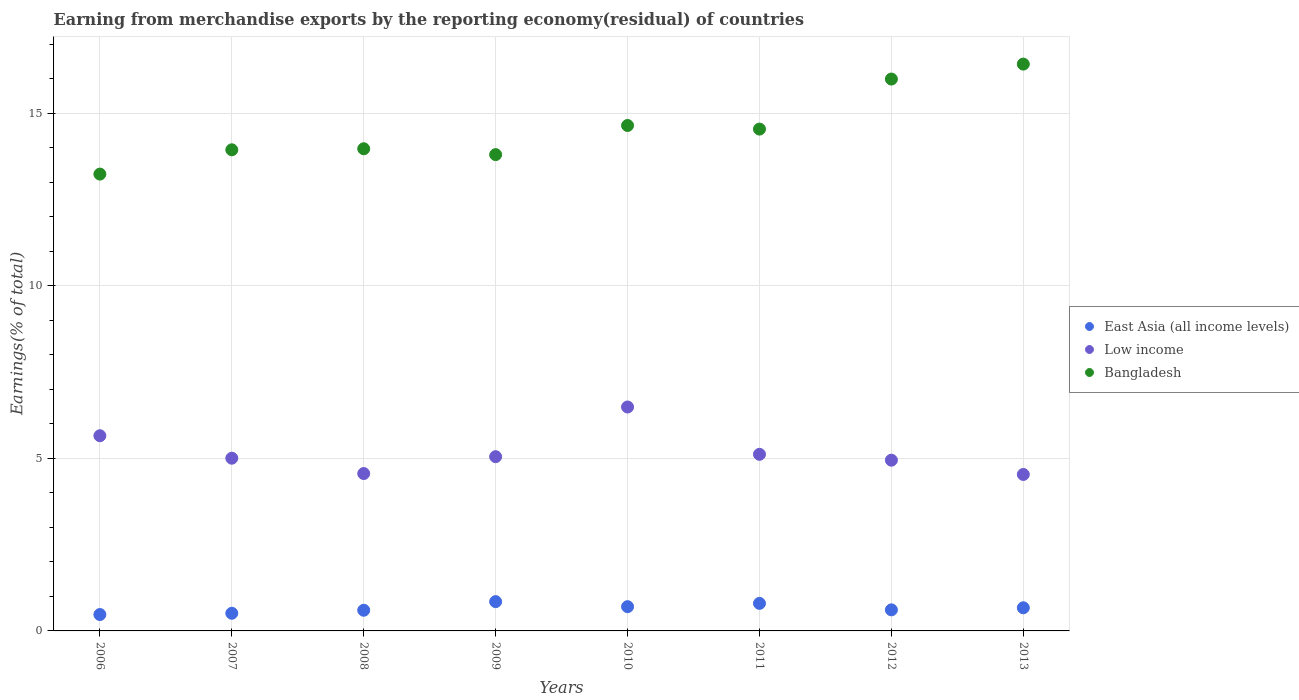What is the percentage of amount earned from merchandise exports in Low income in 2012?
Keep it short and to the point. 4.95. Across all years, what is the maximum percentage of amount earned from merchandise exports in East Asia (all income levels)?
Provide a succinct answer. 0.85. Across all years, what is the minimum percentage of amount earned from merchandise exports in Bangladesh?
Offer a terse response. 13.24. In which year was the percentage of amount earned from merchandise exports in Low income maximum?
Offer a very short reply. 2010. In which year was the percentage of amount earned from merchandise exports in Bangladesh minimum?
Your answer should be compact. 2006. What is the total percentage of amount earned from merchandise exports in East Asia (all income levels) in the graph?
Your answer should be very brief. 5.22. What is the difference between the percentage of amount earned from merchandise exports in Bangladesh in 2007 and that in 2010?
Offer a very short reply. -0.7. What is the difference between the percentage of amount earned from merchandise exports in Low income in 2008 and the percentage of amount earned from merchandise exports in East Asia (all income levels) in 2007?
Make the answer very short. 4.05. What is the average percentage of amount earned from merchandise exports in Bangladesh per year?
Your answer should be compact. 14.57. In the year 2013, what is the difference between the percentage of amount earned from merchandise exports in Bangladesh and percentage of amount earned from merchandise exports in East Asia (all income levels)?
Ensure brevity in your answer.  15.75. What is the ratio of the percentage of amount earned from merchandise exports in East Asia (all income levels) in 2007 to that in 2013?
Your answer should be compact. 0.76. What is the difference between the highest and the second highest percentage of amount earned from merchandise exports in Low income?
Ensure brevity in your answer.  0.83. What is the difference between the highest and the lowest percentage of amount earned from merchandise exports in Low income?
Make the answer very short. 1.95. In how many years, is the percentage of amount earned from merchandise exports in East Asia (all income levels) greater than the average percentage of amount earned from merchandise exports in East Asia (all income levels) taken over all years?
Offer a very short reply. 4. Is it the case that in every year, the sum of the percentage of amount earned from merchandise exports in Bangladesh and percentage of amount earned from merchandise exports in East Asia (all income levels)  is greater than the percentage of amount earned from merchandise exports in Low income?
Provide a succinct answer. Yes. Does the percentage of amount earned from merchandise exports in Bangladesh monotonically increase over the years?
Make the answer very short. No. Is the percentage of amount earned from merchandise exports in East Asia (all income levels) strictly greater than the percentage of amount earned from merchandise exports in Bangladesh over the years?
Your response must be concise. No. What is the difference between two consecutive major ticks on the Y-axis?
Your answer should be compact. 5. Does the graph contain any zero values?
Make the answer very short. No. How are the legend labels stacked?
Your answer should be compact. Vertical. What is the title of the graph?
Ensure brevity in your answer.  Earning from merchandise exports by the reporting economy(residual) of countries. What is the label or title of the Y-axis?
Make the answer very short. Earnings(% of total). What is the Earnings(% of total) in East Asia (all income levels) in 2006?
Provide a succinct answer. 0.47. What is the Earnings(% of total) in Low income in 2006?
Provide a succinct answer. 5.66. What is the Earnings(% of total) of Bangladesh in 2006?
Make the answer very short. 13.24. What is the Earnings(% of total) of East Asia (all income levels) in 2007?
Offer a very short reply. 0.51. What is the Earnings(% of total) of Low income in 2007?
Provide a succinct answer. 5. What is the Earnings(% of total) of Bangladesh in 2007?
Make the answer very short. 13.94. What is the Earnings(% of total) of East Asia (all income levels) in 2008?
Offer a terse response. 0.6. What is the Earnings(% of total) in Low income in 2008?
Your answer should be compact. 4.56. What is the Earnings(% of total) of Bangladesh in 2008?
Ensure brevity in your answer.  13.97. What is the Earnings(% of total) of East Asia (all income levels) in 2009?
Provide a succinct answer. 0.85. What is the Earnings(% of total) of Low income in 2009?
Provide a short and direct response. 5.05. What is the Earnings(% of total) of Bangladesh in 2009?
Your response must be concise. 13.8. What is the Earnings(% of total) of East Asia (all income levels) in 2010?
Offer a very short reply. 0.7. What is the Earnings(% of total) of Low income in 2010?
Your answer should be very brief. 6.49. What is the Earnings(% of total) of Bangladesh in 2010?
Keep it short and to the point. 14.64. What is the Earnings(% of total) in East Asia (all income levels) in 2011?
Make the answer very short. 0.8. What is the Earnings(% of total) in Low income in 2011?
Make the answer very short. 5.12. What is the Earnings(% of total) in Bangladesh in 2011?
Make the answer very short. 14.54. What is the Earnings(% of total) of East Asia (all income levels) in 2012?
Offer a very short reply. 0.61. What is the Earnings(% of total) of Low income in 2012?
Offer a very short reply. 4.95. What is the Earnings(% of total) of Bangladesh in 2012?
Provide a short and direct response. 15.99. What is the Earnings(% of total) in East Asia (all income levels) in 2013?
Offer a terse response. 0.67. What is the Earnings(% of total) in Low income in 2013?
Your answer should be very brief. 4.53. What is the Earnings(% of total) in Bangladesh in 2013?
Your answer should be very brief. 16.42. Across all years, what is the maximum Earnings(% of total) of East Asia (all income levels)?
Your answer should be compact. 0.85. Across all years, what is the maximum Earnings(% of total) in Low income?
Give a very brief answer. 6.49. Across all years, what is the maximum Earnings(% of total) of Bangladesh?
Ensure brevity in your answer.  16.42. Across all years, what is the minimum Earnings(% of total) of East Asia (all income levels)?
Offer a terse response. 0.47. Across all years, what is the minimum Earnings(% of total) of Low income?
Make the answer very short. 4.53. Across all years, what is the minimum Earnings(% of total) of Bangladesh?
Give a very brief answer. 13.24. What is the total Earnings(% of total) of East Asia (all income levels) in the graph?
Offer a terse response. 5.22. What is the total Earnings(% of total) in Low income in the graph?
Your response must be concise. 41.35. What is the total Earnings(% of total) in Bangladesh in the graph?
Your response must be concise. 116.55. What is the difference between the Earnings(% of total) in East Asia (all income levels) in 2006 and that in 2007?
Keep it short and to the point. -0.04. What is the difference between the Earnings(% of total) of Low income in 2006 and that in 2007?
Your response must be concise. 0.65. What is the difference between the Earnings(% of total) in Bangladesh in 2006 and that in 2007?
Your answer should be very brief. -0.7. What is the difference between the Earnings(% of total) of East Asia (all income levels) in 2006 and that in 2008?
Provide a short and direct response. -0.12. What is the difference between the Earnings(% of total) of Low income in 2006 and that in 2008?
Provide a short and direct response. 1.09. What is the difference between the Earnings(% of total) of Bangladesh in 2006 and that in 2008?
Your answer should be very brief. -0.73. What is the difference between the Earnings(% of total) in East Asia (all income levels) in 2006 and that in 2009?
Your answer should be compact. -0.37. What is the difference between the Earnings(% of total) in Low income in 2006 and that in 2009?
Offer a very short reply. 0.61. What is the difference between the Earnings(% of total) in Bangladesh in 2006 and that in 2009?
Your answer should be very brief. -0.56. What is the difference between the Earnings(% of total) in East Asia (all income levels) in 2006 and that in 2010?
Offer a very short reply. -0.23. What is the difference between the Earnings(% of total) of Low income in 2006 and that in 2010?
Give a very brief answer. -0.83. What is the difference between the Earnings(% of total) of Bangladesh in 2006 and that in 2010?
Ensure brevity in your answer.  -1.41. What is the difference between the Earnings(% of total) of East Asia (all income levels) in 2006 and that in 2011?
Provide a short and direct response. -0.32. What is the difference between the Earnings(% of total) of Low income in 2006 and that in 2011?
Your answer should be very brief. 0.54. What is the difference between the Earnings(% of total) of Bangladesh in 2006 and that in 2011?
Provide a succinct answer. -1.3. What is the difference between the Earnings(% of total) of East Asia (all income levels) in 2006 and that in 2012?
Offer a very short reply. -0.14. What is the difference between the Earnings(% of total) of Low income in 2006 and that in 2012?
Offer a terse response. 0.71. What is the difference between the Earnings(% of total) in Bangladesh in 2006 and that in 2012?
Make the answer very short. -2.75. What is the difference between the Earnings(% of total) in East Asia (all income levels) in 2006 and that in 2013?
Your response must be concise. -0.2. What is the difference between the Earnings(% of total) in Low income in 2006 and that in 2013?
Give a very brief answer. 1.12. What is the difference between the Earnings(% of total) of Bangladesh in 2006 and that in 2013?
Offer a very short reply. -3.19. What is the difference between the Earnings(% of total) in East Asia (all income levels) in 2007 and that in 2008?
Offer a terse response. -0.09. What is the difference between the Earnings(% of total) in Low income in 2007 and that in 2008?
Provide a succinct answer. 0.44. What is the difference between the Earnings(% of total) in Bangladesh in 2007 and that in 2008?
Provide a short and direct response. -0.03. What is the difference between the Earnings(% of total) of East Asia (all income levels) in 2007 and that in 2009?
Ensure brevity in your answer.  -0.34. What is the difference between the Earnings(% of total) of Low income in 2007 and that in 2009?
Keep it short and to the point. -0.04. What is the difference between the Earnings(% of total) of Bangladesh in 2007 and that in 2009?
Provide a short and direct response. 0.14. What is the difference between the Earnings(% of total) in East Asia (all income levels) in 2007 and that in 2010?
Your answer should be very brief. -0.19. What is the difference between the Earnings(% of total) of Low income in 2007 and that in 2010?
Make the answer very short. -1.48. What is the difference between the Earnings(% of total) of Bangladesh in 2007 and that in 2010?
Make the answer very short. -0.7. What is the difference between the Earnings(% of total) of East Asia (all income levels) in 2007 and that in 2011?
Keep it short and to the point. -0.29. What is the difference between the Earnings(% of total) in Low income in 2007 and that in 2011?
Provide a succinct answer. -0.11. What is the difference between the Earnings(% of total) in Bangladesh in 2007 and that in 2011?
Provide a succinct answer. -0.6. What is the difference between the Earnings(% of total) in East Asia (all income levels) in 2007 and that in 2012?
Offer a terse response. -0.1. What is the difference between the Earnings(% of total) of Low income in 2007 and that in 2012?
Offer a terse response. 0.06. What is the difference between the Earnings(% of total) in Bangladesh in 2007 and that in 2012?
Your answer should be compact. -2.05. What is the difference between the Earnings(% of total) in East Asia (all income levels) in 2007 and that in 2013?
Offer a terse response. -0.16. What is the difference between the Earnings(% of total) of Low income in 2007 and that in 2013?
Provide a short and direct response. 0.47. What is the difference between the Earnings(% of total) of Bangladesh in 2007 and that in 2013?
Give a very brief answer. -2.48. What is the difference between the Earnings(% of total) in East Asia (all income levels) in 2008 and that in 2009?
Ensure brevity in your answer.  -0.25. What is the difference between the Earnings(% of total) in Low income in 2008 and that in 2009?
Offer a very short reply. -0.49. What is the difference between the Earnings(% of total) in Bangladesh in 2008 and that in 2009?
Make the answer very short. 0.17. What is the difference between the Earnings(% of total) in East Asia (all income levels) in 2008 and that in 2010?
Offer a very short reply. -0.1. What is the difference between the Earnings(% of total) of Low income in 2008 and that in 2010?
Provide a short and direct response. -1.93. What is the difference between the Earnings(% of total) of Bangladesh in 2008 and that in 2010?
Provide a short and direct response. -0.67. What is the difference between the Earnings(% of total) of East Asia (all income levels) in 2008 and that in 2011?
Your response must be concise. -0.2. What is the difference between the Earnings(% of total) of Low income in 2008 and that in 2011?
Provide a succinct answer. -0.56. What is the difference between the Earnings(% of total) of Bangladesh in 2008 and that in 2011?
Your answer should be compact. -0.57. What is the difference between the Earnings(% of total) of East Asia (all income levels) in 2008 and that in 2012?
Provide a short and direct response. -0.01. What is the difference between the Earnings(% of total) in Low income in 2008 and that in 2012?
Your response must be concise. -0.39. What is the difference between the Earnings(% of total) in Bangladesh in 2008 and that in 2012?
Provide a short and direct response. -2.02. What is the difference between the Earnings(% of total) of East Asia (all income levels) in 2008 and that in 2013?
Ensure brevity in your answer.  -0.07. What is the difference between the Earnings(% of total) in Low income in 2008 and that in 2013?
Offer a very short reply. 0.03. What is the difference between the Earnings(% of total) in Bangladesh in 2008 and that in 2013?
Give a very brief answer. -2.45. What is the difference between the Earnings(% of total) in East Asia (all income levels) in 2009 and that in 2010?
Your answer should be very brief. 0.15. What is the difference between the Earnings(% of total) of Low income in 2009 and that in 2010?
Offer a terse response. -1.44. What is the difference between the Earnings(% of total) of Bangladesh in 2009 and that in 2010?
Provide a succinct answer. -0.84. What is the difference between the Earnings(% of total) in East Asia (all income levels) in 2009 and that in 2011?
Your answer should be very brief. 0.05. What is the difference between the Earnings(% of total) in Low income in 2009 and that in 2011?
Your answer should be compact. -0.07. What is the difference between the Earnings(% of total) of Bangladesh in 2009 and that in 2011?
Offer a very short reply. -0.74. What is the difference between the Earnings(% of total) of East Asia (all income levels) in 2009 and that in 2012?
Your response must be concise. 0.24. What is the difference between the Earnings(% of total) in Low income in 2009 and that in 2012?
Provide a succinct answer. 0.1. What is the difference between the Earnings(% of total) in Bangladesh in 2009 and that in 2012?
Provide a short and direct response. -2.19. What is the difference between the Earnings(% of total) of East Asia (all income levels) in 2009 and that in 2013?
Make the answer very short. 0.18. What is the difference between the Earnings(% of total) in Low income in 2009 and that in 2013?
Offer a very short reply. 0.51. What is the difference between the Earnings(% of total) of Bangladesh in 2009 and that in 2013?
Your response must be concise. -2.62. What is the difference between the Earnings(% of total) in East Asia (all income levels) in 2010 and that in 2011?
Ensure brevity in your answer.  -0.1. What is the difference between the Earnings(% of total) in Low income in 2010 and that in 2011?
Provide a succinct answer. 1.37. What is the difference between the Earnings(% of total) of Bangladesh in 2010 and that in 2011?
Offer a terse response. 0.1. What is the difference between the Earnings(% of total) of East Asia (all income levels) in 2010 and that in 2012?
Your answer should be very brief. 0.09. What is the difference between the Earnings(% of total) in Low income in 2010 and that in 2012?
Your answer should be very brief. 1.54. What is the difference between the Earnings(% of total) of Bangladesh in 2010 and that in 2012?
Make the answer very short. -1.35. What is the difference between the Earnings(% of total) in East Asia (all income levels) in 2010 and that in 2013?
Provide a short and direct response. 0.03. What is the difference between the Earnings(% of total) in Low income in 2010 and that in 2013?
Provide a short and direct response. 1.95. What is the difference between the Earnings(% of total) of Bangladesh in 2010 and that in 2013?
Your answer should be very brief. -1.78. What is the difference between the Earnings(% of total) in East Asia (all income levels) in 2011 and that in 2012?
Your response must be concise. 0.19. What is the difference between the Earnings(% of total) of Low income in 2011 and that in 2012?
Ensure brevity in your answer.  0.17. What is the difference between the Earnings(% of total) in Bangladesh in 2011 and that in 2012?
Make the answer very short. -1.45. What is the difference between the Earnings(% of total) in East Asia (all income levels) in 2011 and that in 2013?
Keep it short and to the point. 0.13. What is the difference between the Earnings(% of total) of Low income in 2011 and that in 2013?
Make the answer very short. 0.58. What is the difference between the Earnings(% of total) in Bangladesh in 2011 and that in 2013?
Ensure brevity in your answer.  -1.88. What is the difference between the Earnings(% of total) in East Asia (all income levels) in 2012 and that in 2013?
Give a very brief answer. -0.06. What is the difference between the Earnings(% of total) in Low income in 2012 and that in 2013?
Your answer should be compact. 0.41. What is the difference between the Earnings(% of total) in Bangladesh in 2012 and that in 2013?
Your answer should be very brief. -0.43. What is the difference between the Earnings(% of total) in East Asia (all income levels) in 2006 and the Earnings(% of total) in Low income in 2007?
Your answer should be very brief. -4.53. What is the difference between the Earnings(% of total) of East Asia (all income levels) in 2006 and the Earnings(% of total) of Bangladesh in 2007?
Your answer should be compact. -13.47. What is the difference between the Earnings(% of total) in Low income in 2006 and the Earnings(% of total) in Bangladesh in 2007?
Your answer should be very brief. -8.29. What is the difference between the Earnings(% of total) of East Asia (all income levels) in 2006 and the Earnings(% of total) of Low income in 2008?
Keep it short and to the point. -4.09. What is the difference between the Earnings(% of total) of East Asia (all income levels) in 2006 and the Earnings(% of total) of Bangladesh in 2008?
Make the answer very short. -13.5. What is the difference between the Earnings(% of total) in Low income in 2006 and the Earnings(% of total) in Bangladesh in 2008?
Make the answer very short. -8.32. What is the difference between the Earnings(% of total) of East Asia (all income levels) in 2006 and the Earnings(% of total) of Low income in 2009?
Your response must be concise. -4.57. What is the difference between the Earnings(% of total) in East Asia (all income levels) in 2006 and the Earnings(% of total) in Bangladesh in 2009?
Make the answer very short. -13.33. What is the difference between the Earnings(% of total) in Low income in 2006 and the Earnings(% of total) in Bangladesh in 2009?
Offer a very short reply. -8.15. What is the difference between the Earnings(% of total) in East Asia (all income levels) in 2006 and the Earnings(% of total) in Low income in 2010?
Provide a succinct answer. -6.01. What is the difference between the Earnings(% of total) in East Asia (all income levels) in 2006 and the Earnings(% of total) in Bangladesh in 2010?
Give a very brief answer. -14.17. What is the difference between the Earnings(% of total) in Low income in 2006 and the Earnings(% of total) in Bangladesh in 2010?
Give a very brief answer. -8.99. What is the difference between the Earnings(% of total) in East Asia (all income levels) in 2006 and the Earnings(% of total) in Low income in 2011?
Provide a succinct answer. -4.64. What is the difference between the Earnings(% of total) of East Asia (all income levels) in 2006 and the Earnings(% of total) of Bangladesh in 2011?
Offer a very short reply. -14.07. What is the difference between the Earnings(% of total) in Low income in 2006 and the Earnings(% of total) in Bangladesh in 2011?
Your response must be concise. -8.89. What is the difference between the Earnings(% of total) in East Asia (all income levels) in 2006 and the Earnings(% of total) in Low income in 2012?
Make the answer very short. -4.47. What is the difference between the Earnings(% of total) of East Asia (all income levels) in 2006 and the Earnings(% of total) of Bangladesh in 2012?
Give a very brief answer. -15.52. What is the difference between the Earnings(% of total) in Low income in 2006 and the Earnings(% of total) in Bangladesh in 2012?
Give a very brief answer. -10.34. What is the difference between the Earnings(% of total) of East Asia (all income levels) in 2006 and the Earnings(% of total) of Low income in 2013?
Keep it short and to the point. -4.06. What is the difference between the Earnings(% of total) of East Asia (all income levels) in 2006 and the Earnings(% of total) of Bangladesh in 2013?
Ensure brevity in your answer.  -15.95. What is the difference between the Earnings(% of total) in Low income in 2006 and the Earnings(% of total) in Bangladesh in 2013?
Keep it short and to the point. -10.77. What is the difference between the Earnings(% of total) of East Asia (all income levels) in 2007 and the Earnings(% of total) of Low income in 2008?
Give a very brief answer. -4.05. What is the difference between the Earnings(% of total) in East Asia (all income levels) in 2007 and the Earnings(% of total) in Bangladesh in 2008?
Your answer should be very brief. -13.46. What is the difference between the Earnings(% of total) of Low income in 2007 and the Earnings(% of total) of Bangladesh in 2008?
Make the answer very short. -8.97. What is the difference between the Earnings(% of total) in East Asia (all income levels) in 2007 and the Earnings(% of total) in Low income in 2009?
Your response must be concise. -4.54. What is the difference between the Earnings(% of total) in East Asia (all income levels) in 2007 and the Earnings(% of total) in Bangladesh in 2009?
Provide a short and direct response. -13.29. What is the difference between the Earnings(% of total) of Low income in 2007 and the Earnings(% of total) of Bangladesh in 2009?
Give a very brief answer. -8.8. What is the difference between the Earnings(% of total) in East Asia (all income levels) in 2007 and the Earnings(% of total) in Low income in 2010?
Your answer should be very brief. -5.98. What is the difference between the Earnings(% of total) in East Asia (all income levels) in 2007 and the Earnings(% of total) in Bangladesh in 2010?
Your answer should be very brief. -14.13. What is the difference between the Earnings(% of total) in Low income in 2007 and the Earnings(% of total) in Bangladesh in 2010?
Offer a very short reply. -9.64. What is the difference between the Earnings(% of total) in East Asia (all income levels) in 2007 and the Earnings(% of total) in Low income in 2011?
Offer a very short reply. -4.61. What is the difference between the Earnings(% of total) in East Asia (all income levels) in 2007 and the Earnings(% of total) in Bangladesh in 2011?
Provide a short and direct response. -14.03. What is the difference between the Earnings(% of total) of Low income in 2007 and the Earnings(% of total) of Bangladesh in 2011?
Give a very brief answer. -9.54. What is the difference between the Earnings(% of total) of East Asia (all income levels) in 2007 and the Earnings(% of total) of Low income in 2012?
Give a very brief answer. -4.44. What is the difference between the Earnings(% of total) in East Asia (all income levels) in 2007 and the Earnings(% of total) in Bangladesh in 2012?
Your answer should be very brief. -15.48. What is the difference between the Earnings(% of total) in Low income in 2007 and the Earnings(% of total) in Bangladesh in 2012?
Offer a very short reply. -10.99. What is the difference between the Earnings(% of total) in East Asia (all income levels) in 2007 and the Earnings(% of total) in Low income in 2013?
Make the answer very short. -4.02. What is the difference between the Earnings(% of total) in East Asia (all income levels) in 2007 and the Earnings(% of total) in Bangladesh in 2013?
Keep it short and to the point. -15.91. What is the difference between the Earnings(% of total) in Low income in 2007 and the Earnings(% of total) in Bangladesh in 2013?
Give a very brief answer. -11.42. What is the difference between the Earnings(% of total) of East Asia (all income levels) in 2008 and the Earnings(% of total) of Low income in 2009?
Make the answer very short. -4.45. What is the difference between the Earnings(% of total) of East Asia (all income levels) in 2008 and the Earnings(% of total) of Bangladesh in 2009?
Your response must be concise. -13.2. What is the difference between the Earnings(% of total) in Low income in 2008 and the Earnings(% of total) in Bangladesh in 2009?
Keep it short and to the point. -9.24. What is the difference between the Earnings(% of total) in East Asia (all income levels) in 2008 and the Earnings(% of total) in Low income in 2010?
Your answer should be very brief. -5.89. What is the difference between the Earnings(% of total) in East Asia (all income levels) in 2008 and the Earnings(% of total) in Bangladesh in 2010?
Offer a terse response. -14.05. What is the difference between the Earnings(% of total) of Low income in 2008 and the Earnings(% of total) of Bangladesh in 2010?
Give a very brief answer. -10.08. What is the difference between the Earnings(% of total) of East Asia (all income levels) in 2008 and the Earnings(% of total) of Low income in 2011?
Provide a short and direct response. -4.52. What is the difference between the Earnings(% of total) in East Asia (all income levels) in 2008 and the Earnings(% of total) in Bangladesh in 2011?
Offer a very short reply. -13.94. What is the difference between the Earnings(% of total) in Low income in 2008 and the Earnings(% of total) in Bangladesh in 2011?
Make the answer very short. -9.98. What is the difference between the Earnings(% of total) in East Asia (all income levels) in 2008 and the Earnings(% of total) in Low income in 2012?
Make the answer very short. -4.35. What is the difference between the Earnings(% of total) of East Asia (all income levels) in 2008 and the Earnings(% of total) of Bangladesh in 2012?
Offer a terse response. -15.39. What is the difference between the Earnings(% of total) in Low income in 2008 and the Earnings(% of total) in Bangladesh in 2012?
Your response must be concise. -11.43. What is the difference between the Earnings(% of total) in East Asia (all income levels) in 2008 and the Earnings(% of total) in Low income in 2013?
Give a very brief answer. -3.93. What is the difference between the Earnings(% of total) of East Asia (all income levels) in 2008 and the Earnings(% of total) of Bangladesh in 2013?
Keep it short and to the point. -15.82. What is the difference between the Earnings(% of total) of Low income in 2008 and the Earnings(% of total) of Bangladesh in 2013?
Offer a terse response. -11.86. What is the difference between the Earnings(% of total) of East Asia (all income levels) in 2009 and the Earnings(% of total) of Low income in 2010?
Offer a terse response. -5.64. What is the difference between the Earnings(% of total) of East Asia (all income levels) in 2009 and the Earnings(% of total) of Bangladesh in 2010?
Your answer should be compact. -13.8. What is the difference between the Earnings(% of total) of Low income in 2009 and the Earnings(% of total) of Bangladesh in 2010?
Give a very brief answer. -9.6. What is the difference between the Earnings(% of total) in East Asia (all income levels) in 2009 and the Earnings(% of total) in Low income in 2011?
Keep it short and to the point. -4.27. What is the difference between the Earnings(% of total) in East Asia (all income levels) in 2009 and the Earnings(% of total) in Bangladesh in 2011?
Provide a short and direct response. -13.69. What is the difference between the Earnings(% of total) of Low income in 2009 and the Earnings(% of total) of Bangladesh in 2011?
Keep it short and to the point. -9.49. What is the difference between the Earnings(% of total) of East Asia (all income levels) in 2009 and the Earnings(% of total) of Low income in 2012?
Provide a succinct answer. -4.1. What is the difference between the Earnings(% of total) of East Asia (all income levels) in 2009 and the Earnings(% of total) of Bangladesh in 2012?
Offer a terse response. -15.14. What is the difference between the Earnings(% of total) in Low income in 2009 and the Earnings(% of total) in Bangladesh in 2012?
Provide a short and direct response. -10.94. What is the difference between the Earnings(% of total) of East Asia (all income levels) in 2009 and the Earnings(% of total) of Low income in 2013?
Your answer should be compact. -3.68. What is the difference between the Earnings(% of total) in East Asia (all income levels) in 2009 and the Earnings(% of total) in Bangladesh in 2013?
Give a very brief answer. -15.57. What is the difference between the Earnings(% of total) of Low income in 2009 and the Earnings(% of total) of Bangladesh in 2013?
Your response must be concise. -11.38. What is the difference between the Earnings(% of total) of East Asia (all income levels) in 2010 and the Earnings(% of total) of Low income in 2011?
Offer a very short reply. -4.41. What is the difference between the Earnings(% of total) in East Asia (all income levels) in 2010 and the Earnings(% of total) in Bangladesh in 2011?
Your answer should be very brief. -13.84. What is the difference between the Earnings(% of total) in Low income in 2010 and the Earnings(% of total) in Bangladesh in 2011?
Provide a short and direct response. -8.05. What is the difference between the Earnings(% of total) in East Asia (all income levels) in 2010 and the Earnings(% of total) in Low income in 2012?
Keep it short and to the point. -4.24. What is the difference between the Earnings(% of total) of East Asia (all income levels) in 2010 and the Earnings(% of total) of Bangladesh in 2012?
Give a very brief answer. -15.29. What is the difference between the Earnings(% of total) in Low income in 2010 and the Earnings(% of total) in Bangladesh in 2012?
Offer a terse response. -9.5. What is the difference between the Earnings(% of total) in East Asia (all income levels) in 2010 and the Earnings(% of total) in Low income in 2013?
Make the answer very short. -3.83. What is the difference between the Earnings(% of total) of East Asia (all income levels) in 2010 and the Earnings(% of total) of Bangladesh in 2013?
Ensure brevity in your answer.  -15.72. What is the difference between the Earnings(% of total) of Low income in 2010 and the Earnings(% of total) of Bangladesh in 2013?
Provide a succinct answer. -9.94. What is the difference between the Earnings(% of total) of East Asia (all income levels) in 2011 and the Earnings(% of total) of Low income in 2012?
Your answer should be compact. -4.15. What is the difference between the Earnings(% of total) of East Asia (all income levels) in 2011 and the Earnings(% of total) of Bangladesh in 2012?
Ensure brevity in your answer.  -15.19. What is the difference between the Earnings(% of total) in Low income in 2011 and the Earnings(% of total) in Bangladesh in 2012?
Offer a terse response. -10.87. What is the difference between the Earnings(% of total) of East Asia (all income levels) in 2011 and the Earnings(% of total) of Low income in 2013?
Your answer should be compact. -3.74. What is the difference between the Earnings(% of total) in East Asia (all income levels) in 2011 and the Earnings(% of total) in Bangladesh in 2013?
Provide a short and direct response. -15.63. What is the difference between the Earnings(% of total) of Low income in 2011 and the Earnings(% of total) of Bangladesh in 2013?
Give a very brief answer. -11.31. What is the difference between the Earnings(% of total) in East Asia (all income levels) in 2012 and the Earnings(% of total) in Low income in 2013?
Offer a terse response. -3.92. What is the difference between the Earnings(% of total) in East Asia (all income levels) in 2012 and the Earnings(% of total) in Bangladesh in 2013?
Your response must be concise. -15.81. What is the difference between the Earnings(% of total) in Low income in 2012 and the Earnings(% of total) in Bangladesh in 2013?
Your answer should be very brief. -11.48. What is the average Earnings(% of total) in East Asia (all income levels) per year?
Make the answer very short. 0.65. What is the average Earnings(% of total) of Low income per year?
Keep it short and to the point. 5.17. What is the average Earnings(% of total) in Bangladesh per year?
Offer a terse response. 14.57. In the year 2006, what is the difference between the Earnings(% of total) in East Asia (all income levels) and Earnings(% of total) in Low income?
Your answer should be very brief. -5.18. In the year 2006, what is the difference between the Earnings(% of total) of East Asia (all income levels) and Earnings(% of total) of Bangladesh?
Offer a very short reply. -12.76. In the year 2006, what is the difference between the Earnings(% of total) in Low income and Earnings(% of total) in Bangladesh?
Your answer should be compact. -7.58. In the year 2007, what is the difference between the Earnings(% of total) of East Asia (all income levels) and Earnings(% of total) of Low income?
Give a very brief answer. -4.49. In the year 2007, what is the difference between the Earnings(% of total) of East Asia (all income levels) and Earnings(% of total) of Bangladesh?
Your response must be concise. -13.43. In the year 2007, what is the difference between the Earnings(% of total) of Low income and Earnings(% of total) of Bangladesh?
Offer a terse response. -8.94. In the year 2008, what is the difference between the Earnings(% of total) in East Asia (all income levels) and Earnings(% of total) in Low income?
Your answer should be very brief. -3.96. In the year 2008, what is the difference between the Earnings(% of total) in East Asia (all income levels) and Earnings(% of total) in Bangladesh?
Your answer should be compact. -13.37. In the year 2008, what is the difference between the Earnings(% of total) in Low income and Earnings(% of total) in Bangladesh?
Your answer should be compact. -9.41. In the year 2009, what is the difference between the Earnings(% of total) of East Asia (all income levels) and Earnings(% of total) of Low income?
Your response must be concise. -4.2. In the year 2009, what is the difference between the Earnings(% of total) in East Asia (all income levels) and Earnings(% of total) in Bangladesh?
Your answer should be compact. -12.95. In the year 2009, what is the difference between the Earnings(% of total) of Low income and Earnings(% of total) of Bangladesh?
Keep it short and to the point. -8.75. In the year 2010, what is the difference between the Earnings(% of total) of East Asia (all income levels) and Earnings(% of total) of Low income?
Make the answer very short. -5.79. In the year 2010, what is the difference between the Earnings(% of total) in East Asia (all income levels) and Earnings(% of total) in Bangladesh?
Your answer should be compact. -13.94. In the year 2010, what is the difference between the Earnings(% of total) of Low income and Earnings(% of total) of Bangladesh?
Provide a succinct answer. -8.16. In the year 2011, what is the difference between the Earnings(% of total) in East Asia (all income levels) and Earnings(% of total) in Low income?
Your answer should be compact. -4.32. In the year 2011, what is the difference between the Earnings(% of total) of East Asia (all income levels) and Earnings(% of total) of Bangladesh?
Provide a short and direct response. -13.74. In the year 2011, what is the difference between the Earnings(% of total) in Low income and Earnings(% of total) in Bangladesh?
Your answer should be compact. -9.42. In the year 2012, what is the difference between the Earnings(% of total) of East Asia (all income levels) and Earnings(% of total) of Low income?
Provide a short and direct response. -4.34. In the year 2012, what is the difference between the Earnings(% of total) in East Asia (all income levels) and Earnings(% of total) in Bangladesh?
Your response must be concise. -15.38. In the year 2012, what is the difference between the Earnings(% of total) in Low income and Earnings(% of total) in Bangladesh?
Offer a terse response. -11.04. In the year 2013, what is the difference between the Earnings(% of total) of East Asia (all income levels) and Earnings(% of total) of Low income?
Offer a very short reply. -3.86. In the year 2013, what is the difference between the Earnings(% of total) of East Asia (all income levels) and Earnings(% of total) of Bangladesh?
Your answer should be compact. -15.75. In the year 2013, what is the difference between the Earnings(% of total) in Low income and Earnings(% of total) in Bangladesh?
Your answer should be compact. -11.89. What is the ratio of the Earnings(% of total) in East Asia (all income levels) in 2006 to that in 2007?
Make the answer very short. 0.93. What is the ratio of the Earnings(% of total) in Low income in 2006 to that in 2007?
Make the answer very short. 1.13. What is the ratio of the Earnings(% of total) in Bangladesh in 2006 to that in 2007?
Provide a succinct answer. 0.95. What is the ratio of the Earnings(% of total) in East Asia (all income levels) in 2006 to that in 2008?
Keep it short and to the point. 0.79. What is the ratio of the Earnings(% of total) of Low income in 2006 to that in 2008?
Provide a succinct answer. 1.24. What is the ratio of the Earnings(% of total) of Bangladesh in 2006 to that in 2008?
Your answer should be compact. 0.95. What is the ratio of the Earnings(% of total) of East Asia (all income levels) in 2006 to that in 2009?
Your response must be concise. 0.56. What is the ratio of the Earnings(% of total) of Low income in 2006 to that in 2009?
Ensure brevity in your answer.  1.12. What is the ratio of the Earnings(% of total) in Bangladesh in 2006 to that in 2009?
Give a very brief answer. 0.96. What is the ratio of the Earnings(% of total) of East Asia (all income levels) in 2006 to that in 2010?
Provide a succinct answer. 0.68. What is the ratio of the Earnings(% of total) in Low income in 2006 to that in 2010?
Provide a succinct answer. 0.87. What is the ratio of the Earnings(% of total) of Bangladesh in 2006 to that in 2010?
Give a very brief answer. 0.9. What is the ratio of the Earnings(% of total) in East Asia (all income levels) in 2006 to that in 2011?
Your response must be concise. 0.6. What is the ratio of the Earnings(% of total) of Low income in 2006 to that in 2011?
Ensure brevity in your answer.  1.11. What is the ratio of the Earnings(% of total) in Bangladesh in 2006 to that in 2011?
Keep it short and to the point. 0.91. What is the ratio of the Earnings(% of total) of East Asia (all income levels) in 2006 to that in 2012?
Ensure brevity in your answer.  0.78. What is the ratio of the Earnings(% of total) in Low income in 2006 to that in 2012?
Keep it short and to the point. 1.14. What is the ratio of the Earnings(% of total) of Bangladesh in 2006 to that in 2012?
Your response must be concise. 0.83. What is the ratio of the Earnings(% of total) in East Asia (all income levels) in 2006 to that in 2013?
Ensure brevity in your answer.  0.71. What is the ratio of the Earnings(% of total) in Low income in 2006 to that in 2013?
Your answer should be compact. 1.25. What is the ratio of the Earnings(% of total) of Bangladesh in 2006 to that in 2013?
Offer a very short reply. 0.81. What is the ratio of the Earnings(% of total) of East Asia (all income levels) in 2007 to that in 2008?
Offer a terse response. 0.85. What is the ratio of the Earnings(% of total) of Low income in 2007 to that in 2008?
Provide a short and direct response. 1.1. What is the ratio of the Earnings(% of total) in Bangladesh in 2007 to that in 2008?
Your answer should be very brief. 1. What is the ratio of the Earnings(% of total) in East Asia (all income levels) in 2007 to that in 2009?
Your response must be concise. 0.6. What is the ratio of the Earnings(% of total) in East Asia (all income levels) in 2007 to that in 2010?
Your answer should be compact. 0.73. What is the ratio of the Earnings(% of total) of Low income in 2007 to that in 2010?
Make the answer very short. 0.77. What is the ratio of the Earnings(% of total) of Bangladesh in 2007 to that in 2010?
Offer a very short reply. 0.95. What is the ratio of the Earnings(% of total) of East Asia (all income levels) in 2007 to that in 2011?
Offer a very short reply. 0.64. What is the ratio of the Earnings(% of total) of Low income in 2007 to that in 2011?
Keep it short and to the point. 0.98. What is the ratio of the Earnings(% of total) in Bangladesh in 2007 to that in 2011?
Keep it short and to the point. 0.96. What is the ratio of the Earnings(% of total) of East Asia (all income levels) in 2007 to that in 2012?
Provide a succinct answer. 0.84. What is the ratio of the Earnings(% of total) of Low income in 2007 to that in 2012?
Your answer should be very brief. 1.01. What is the ratio of the Earnings(% of total) of Bangladesh in 2007 to that in 2012?
Make the answer very short. 0.87. What is the ratio of the Earnings(% of total) in East Asia (all income levels) in 2007 to that in 2013?
Keep it short and to the point. 0.76. What is the ratio of the Earnings(% of total) in Low income in 2007 to that in 2013?
Provide a succinct answer. 1.1. What is the ratio of the Earnings(% of total) in Bangladesh in 2007 to that in 2013?
Provide a short and direct response. 0.85. What is the ratio of the Earnings(% of total) of East Asia (all income levels) in 2008 to that in 2009?
Offer a terse response. 0.71. What is the ratio of the Earnings(% of total) of Low income in 2008 to that in 2009?
Offer a terse response. 0.9. What is the ratio of the Earnings(% of total) in Bangladesh in 2008 to that in 2009?
Your response must be concise. 1.01. What is the ratio of the Earnings(% of total) in East Asia (all income levels) in 2008 to that in 2010?
Keep it short and to the point. 0.85. What is the ratio of the Earnings(% of total) in Low income in 2008 to that in 2010?
Offer a very short reply. 0.7. What is the ratio of the Earnings(% of total) of Bangladesh in 2008 to that in 2010?
Your answer should be compact. 0.95. What is the ratio of the Earnings(% of total) in East Asia (all income levels) in 2008 to that in 2011?
Make the answer very short. 0.75. What is the ratio of the Earnings(% of total) of Low income in 2008 to that in 2011?
Your response must be concise. 0.89. What is the ratio of the Earnings(% of total) in Bangladesh in 2008 to that in 2011?
Ensure brevity in your answer.  0.96. What is the ratio of the Earnings(% of total) in East Asia (all income levels) in 2008 to that in 2012?
Offer a terse response. 0.98. What is the ratio of the Earnings(% of total) of Low income in 2008 to that in 2012?
Provide a succinct answer. 0.92. What is the ratio of the Earnings(% of total) of Bangladesh in 2008 to that in 2012?
Give a very brief answer. 0.87. What is the ratio of the Earnings(% of total) of East Asia (all income levels) in 2008 to that in 2013?
Make the answer very short. 0.89. What is the ratio of the Earnings(% of total) in Low income in 2008 to that in 2013?
Offer a terse response. 1.01. What is the ratio of the Earnings(% of total) of Bangladesh in 2008 to that in 2013?
Your response must be concise. 0.85. What is the ratio of the Earnings(% of total) in East Asia (all income levels) in 2009 to that in 2010?
Give a very brief answer. 1.21. What is the ratio of the Earnings(% of total) of Low income in 2009 to that in 2010?
Ensure brevity in your answer.  0.78. What is the ratio of the Earnings(% of total) in Bangladesh in 2009 to that in 2010?
Your answer should be compact. 0.94. What is the ratio of the Earnings(% of total) of East Asia (all income levels) in 2009 to that in 2011?
Keep it short and to the point. 1.06. What is the ratio of the Earnings(% of total) in Low income in 2009 to that in 2011?
Offer a very short reply. 0.99. What is the ratio of the Earnings(% of total) of Bangladesh in 2009 to that in 2011?
Your answer should be compact. 0.95. What is the ratio of the Earnings(% of total) of East Asia (all income levels) in 2009 to that in 2012?
Make the answer very short. 1.39. What is the ratio of the Earnings(% of total) in Low income in 2009 to that in 2012?
Offer a terse response. 1.02. What is the ratio of the Earnings(% of total) of Bangladesh in 2009 to that in 2012?
Offer a terse response. 0.86. What is the ratio of the Earnings(% of total) in East Asia (all income levels) in 2009 to that in 2013?
Your response must be concise. 1.27. What is the ratio of the Earnings(% of total) of Low income in 2009 to that in 2013?
Your response must be concise. 1.11. What is the ratio of the Earnings(% of total) in Bangladesh in 2009 to that in 2013?
Provide a short and direct response. 0.84. What is the ratio of the Earnings(% of total) of East Asia (all income levels) in 2010 to that in 2011?
Provide a short and direct response. 0.88. What is the ratio of the Earnings(% of total) of Low income in 2010 to that in 2011?
Provide a succinct answer. 1.27. What is the ratio of the Earnings(% of total) in Bangladesh in 2010 to that in 2011?
Give a very brief answer. 1.01. What is the ratio of the Earnings(% of total) of East Asia (all income levels) in 2010 to that in 2012?
Give a very brief answer. 1.15. What is the ratio of the Earnings(% of total) of Low income in 2010 to that in 2012?
Offer a very short reply. 1.31. What is the ratio of the Earnings(% of total) of Bangladesh in 2010 to that in 2012?
Ensure brevity in your answer.  0.92. What is the ratio of the Earnings(% of total) in East Asia (all income levels) in 2010 to that in 2013?
Offer a terse response. 1.05. What is the ratio of the Earnings(% of total) of Low income in 2010 to that in 2013?
Your response must be concise. 1.43. What is the ratio of the Earnings(% of total) of Bangladesh in 2010 to that in 2013?
Make the answer very short. 0.89. What is the ratio of the Earnings(% of total) in East Asia (all income levels) in 2011 to that in 2012?
Give a very brief answer. 1.31. What is the ratio of the Earnings(% of total) of Low income in 2011 to that in 2012?
Give a very brief answer. 1.03. What is the ratio of the Earnings(% of total) of Bangladesh in 2011 to that in 2012?
Give a very brief answer. 0.91. What is the ratio of the Earnings(% of total) in East Asia (all income levels) in 2011 to that in 2013?
Your response must be concise. 1.19. What is the ratio of the Earnings(% of total) of Low income in 2011 to that in 2013?
Give a very brief answer. 1.13. What is the ratio of the Earnings(% of total) in Bangladesh in 2011 to that in 2013?
Your answer should be very brief. 0.89. What is the ratio of the Earnings(% of total) in East Asia (all income levels) in 2012 to that in 2013?
Your answer should be very brief. 0.91. What is the ratio of the Earnings(% of total) of Low income in 2012 to that in 2013?
Keep it short and to the point. 1.09. What is the ratio of the Earnings(% of total) of Bangladesh in 2012 to that in 2013?
Offer a very short reply. 0.97. What is the difference between the highest and the second highest Earnings(% of total) of East Asia (all income levels)?
Your response must be concise. 0.05. What is the difference between the highest and the second highest Earnings(% of total) of Low income?
Give a very brief answer. 0.83. What is the difference between the highest and the second highest Earnings(% of total) of Bangladesh?
Provide a succinct answer. 0.43. What is the difference between the highest and the lowest Earnings(% of total) in East Asia (all income levels)?
Your response must be concise. 0.37. What is the difference between the highest and the lowest Earnings(% of total) in Low income?
Offer a terse response. 1.95. What is the difference between the highest and the lowest Earnings(% of total) in Bangladesh?
Offer a terse response. 3.19. 